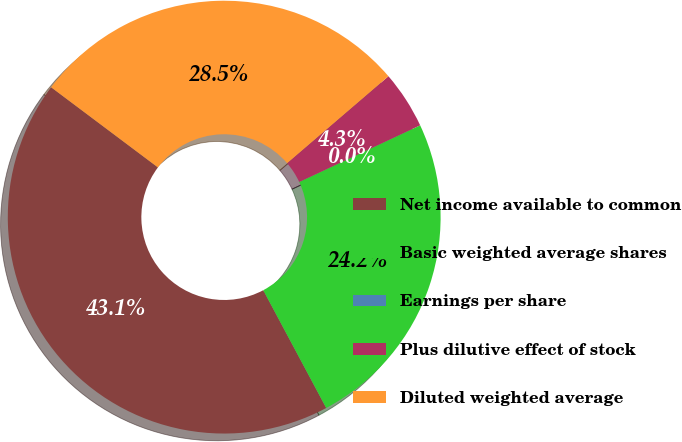Convert chart to OTSL. <chart><loc_0><loc_0><loc_500><loc_500><pie_chart><fcel>Net income available to common<fcel>Basic weighted average shares<fcel>Earnings per share<fcel>Plus dilutive effect of stock<fcel>Diluted weighted average<nl><fcel>43.06%<fcel>24.16%<fcel>0.0%<fcel>4.31%<fcel>28.47%<nl></chart> 